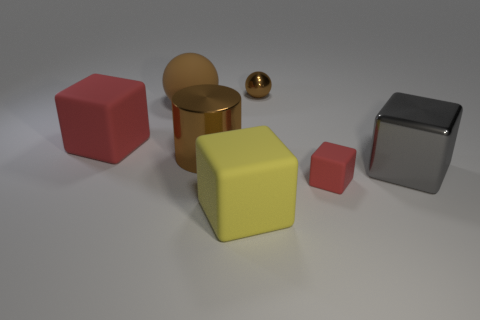How many red blocks must be subtracted to get 1 red blocks? 1 Subtract all shiny blocks. How many blocks are left? 3 Subtract all gray blocks. How many blocks are left? 3 Subtract all brown cylinders. How many red cubes are left? 2 Subtract all cyan cubes. Subtract all purple cylinders. How many cubes are left? 4 Add 3 tiny blue metal blocks. How many objects exist? 10 Add 5 large green metal blocks. How many large green metal blocks exist? 5 Subtract 0 purple cylinders. How many objects are left? 7 Subtract all spheres. How many objects are left? 5 Subtract all big shiny cylinders. Subtract all cylinders. How many objects are left? 5 